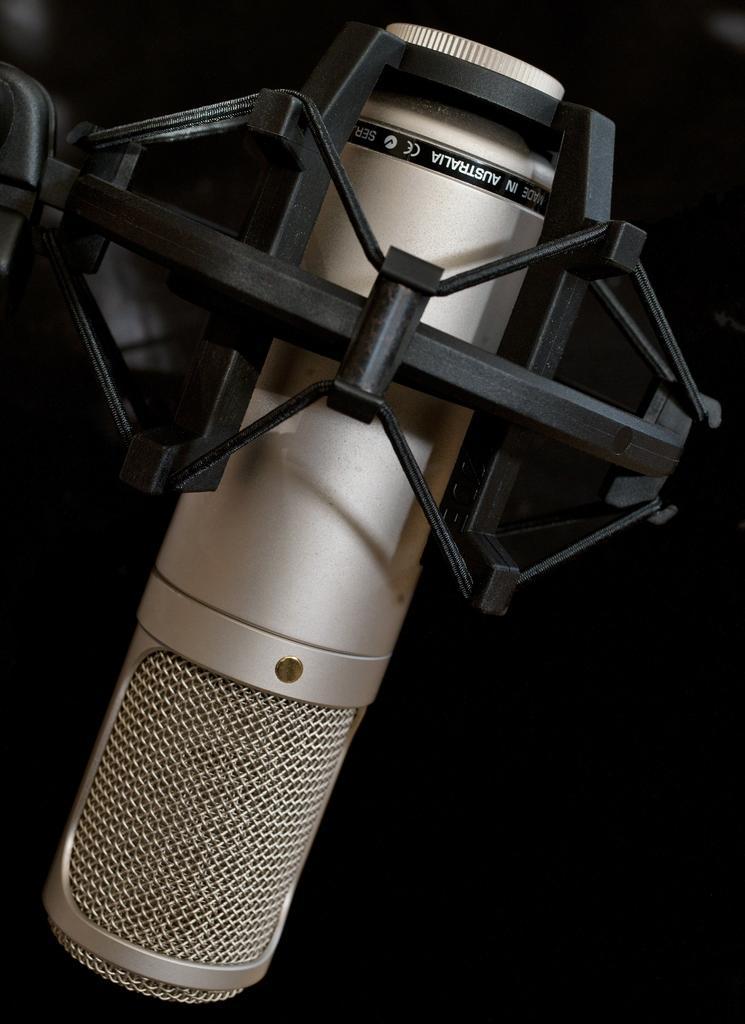Could you give a brief overview of what you see in this image? In this image a microphone is there of silver white and black in color, which is kept. The background is dark in color. This image is taken on the stage. 